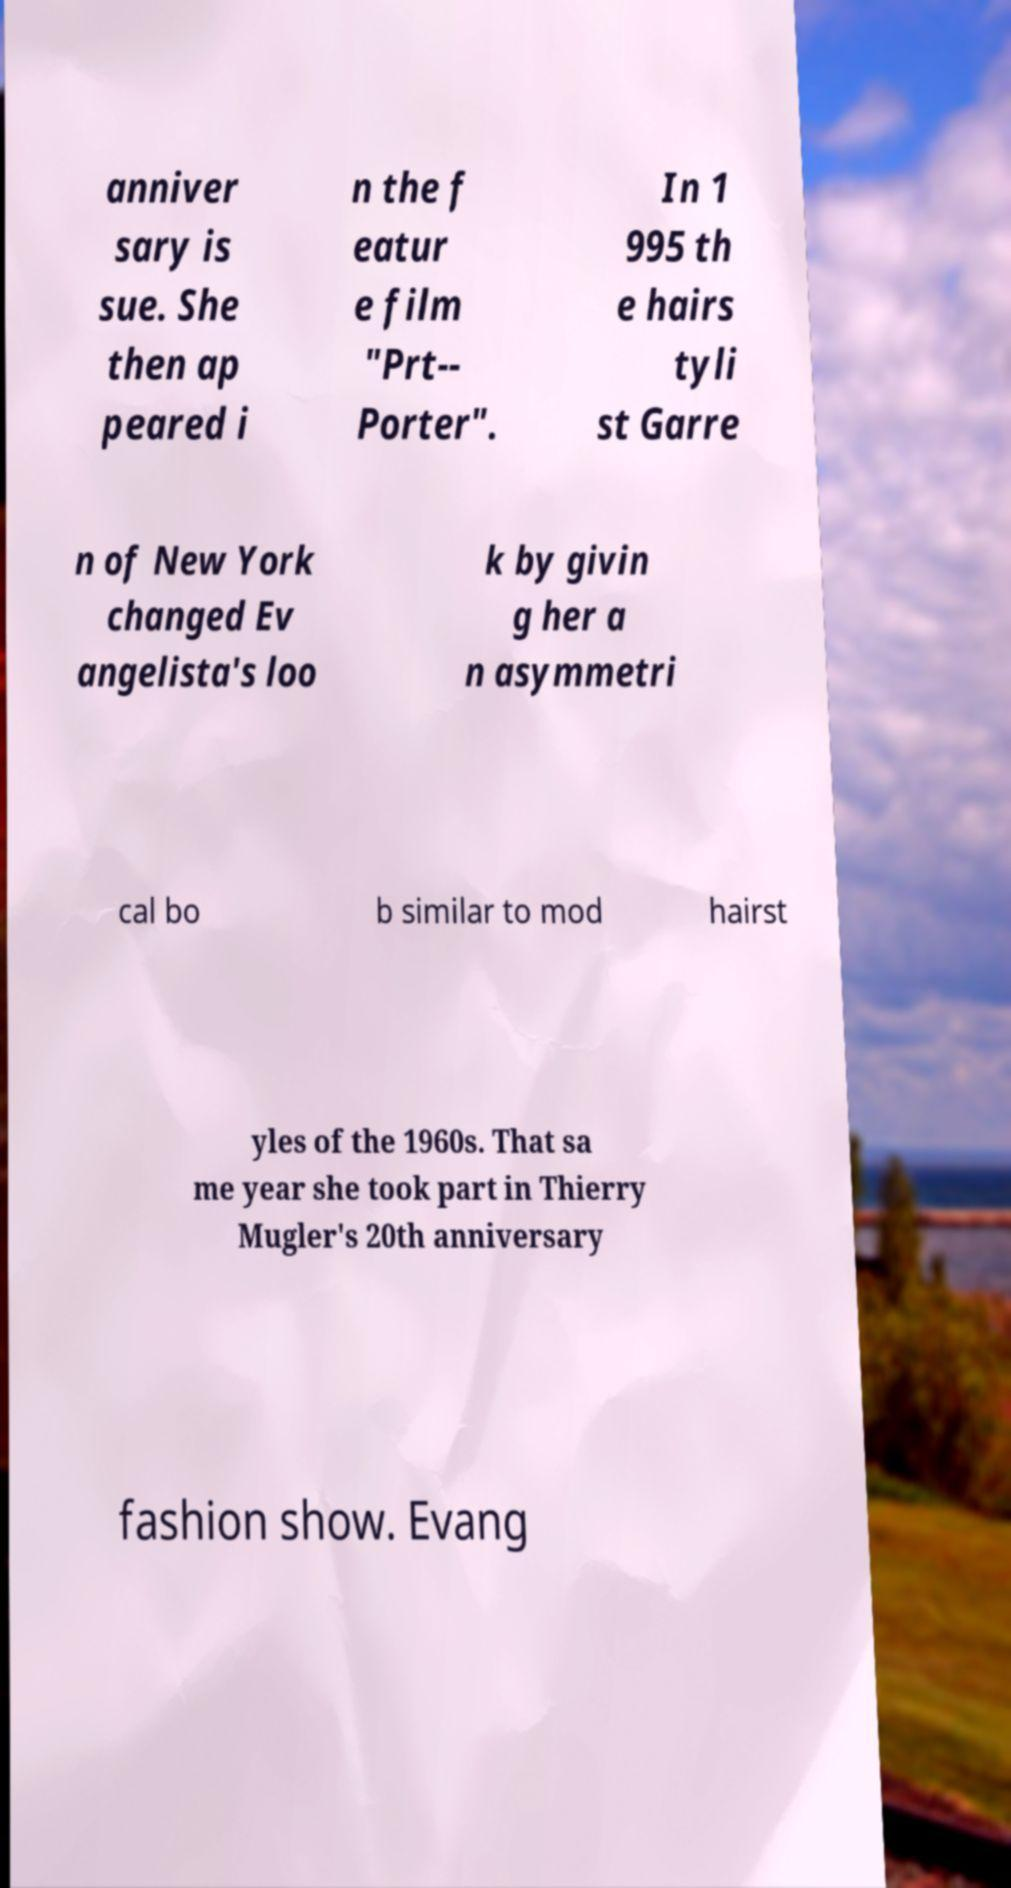Can you accurately transcribe the text from the provided image for me? anniver sary is sue. She then ap peared i n the f eatur e film "Prt-- Porter". In 1 995 th e hairs tyli st Garre n of New York changed Ev angelista's loo k by givin g her a n asymmetri cal bo b similar to mod hairst yles of the 1960s. That sa me year she took part in Thierry Mugler's 20th anniversary fashion show. Evang 